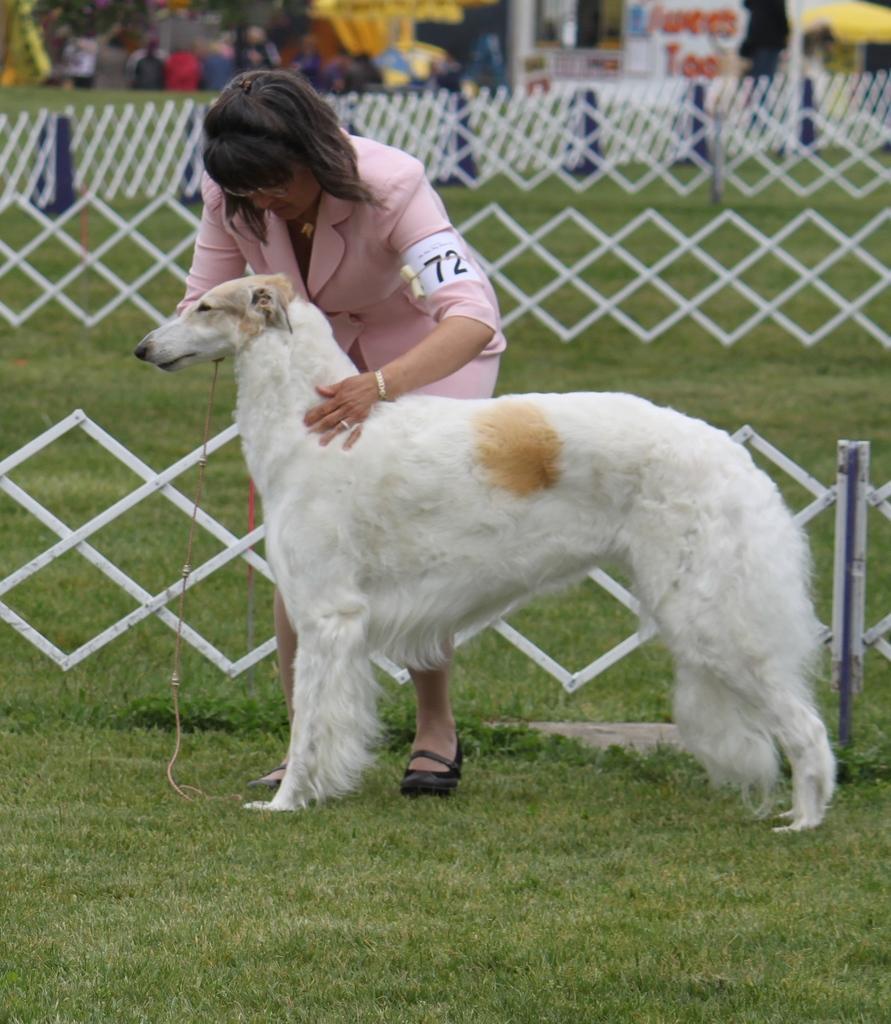Can you describe this image briefly? In this picture a lady is catching a white dog and the scene is clicked in a farm, which has also a white fencing. In the background we observe many toys and kids play. 